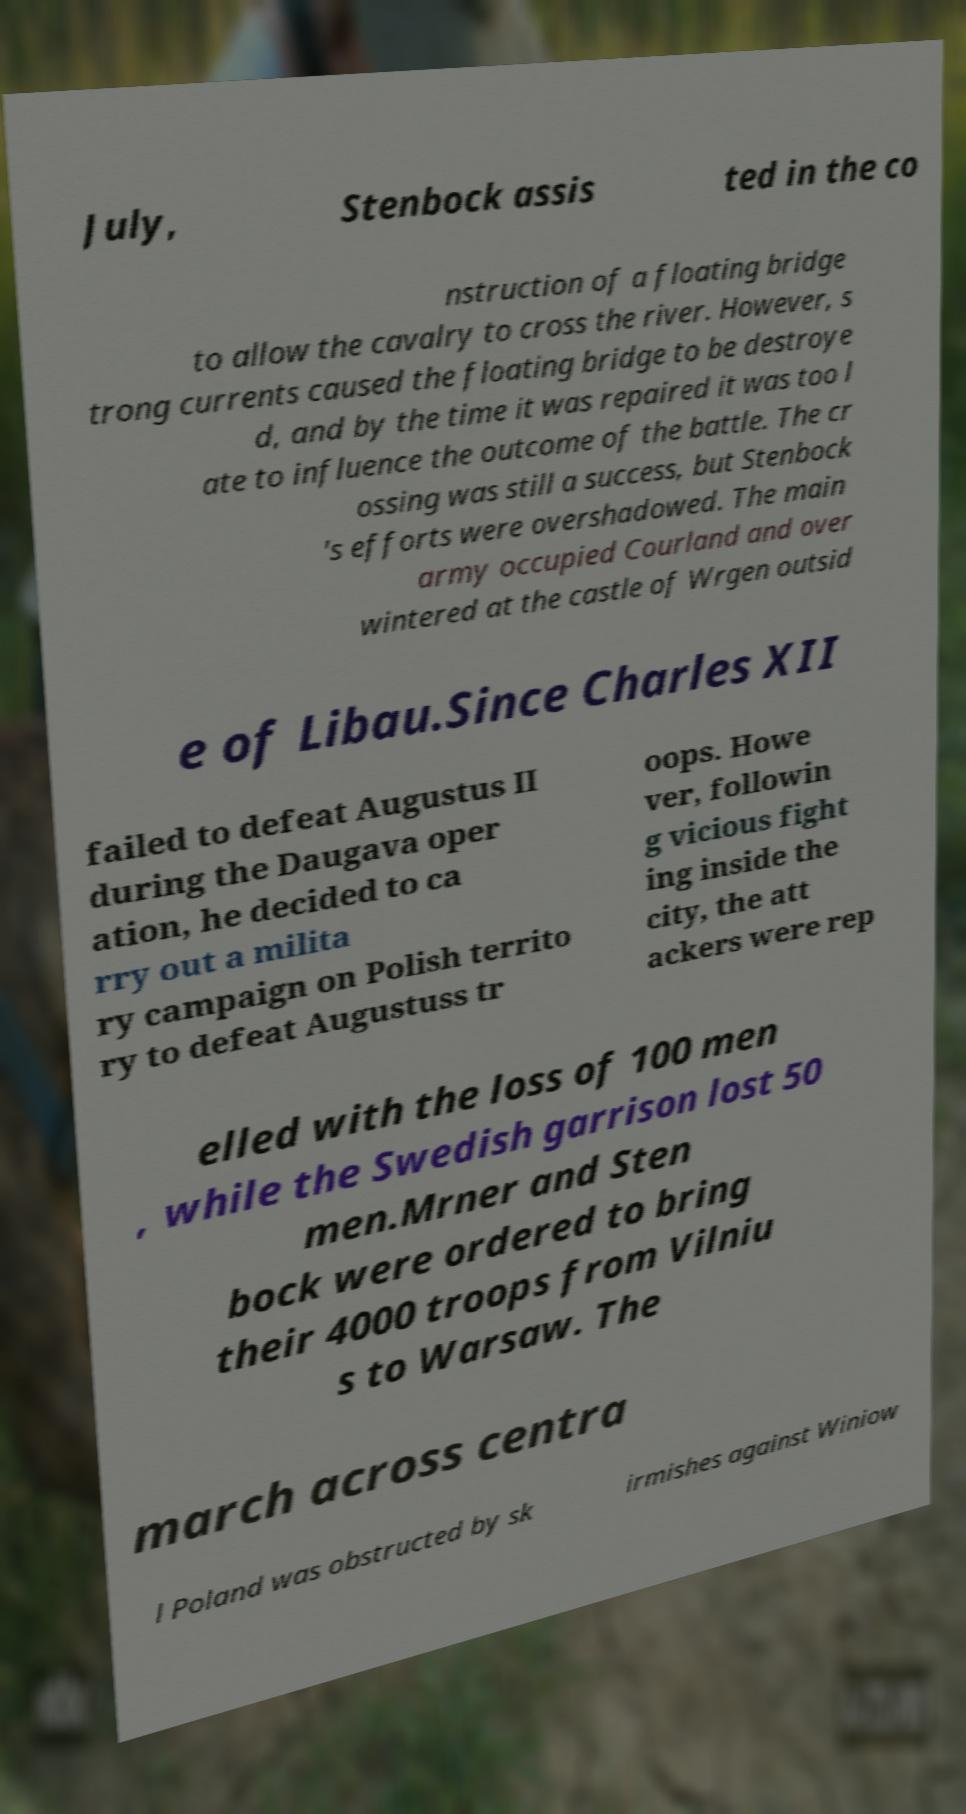What messages or text are displayed in this image? I need them in a readable, typed format. July, Stenbock assis ted in the co nstruction of a floating bridge to allow the cavalry to cross the river. However, s trong currents caused the floating bridge to be destroye d, and by the time it was repaired it was too l ate to influence the outcome of the battle. The cr ossing was still a success, but Stenbock 's efforts were overshadowed. The main army occupied Courland and over wintered at the castle of Wrgen outsid e of Libau.Since Charles XII failed to defeat Augustus II during the Daugava oper ation, he decided to ca rry out a milita ry campaign on Polish territo ry to defeat Augustuss tr oops. Howe ver, followin g vicious fight ing inside the city, the att ackers were rep elled with the loss of 100 men , while the Swedish garrison lost 50 men.Mrner and Sten bock were ordered to bring their 4000 troops from Vilniu s to Warsaw. The march across centra l Poland was obstructed by sk irmishes against Winiow 